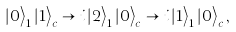<formula> <loc_0><loc_0><loc_500><loc_500>\left | 0 \right \rangle _ { 1 } \left | 1 \right \rangle _ { c } \rightarrow i \left | 2 \right \rangle _ { 1 } \left | 0 \right \rangle _ { c } \rightarrow i \left | 1 \right \rangle _ { 1 } \left | 0 \right \rangle _ { c } ,</formula> 